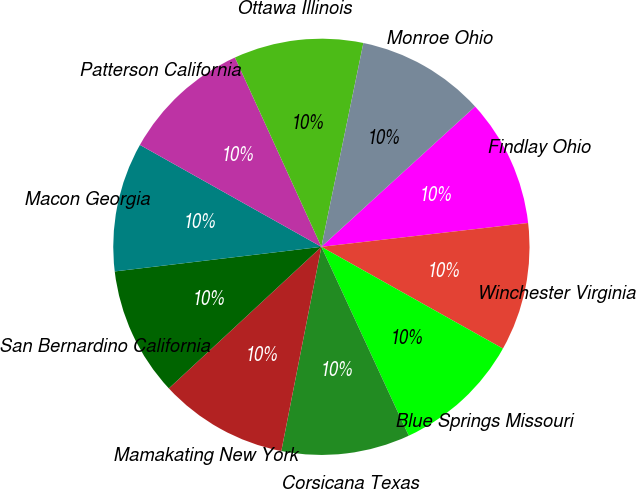Convert chart. <chart><loc_0><loc_0><loc_500><loc_500><pie_chart><fcel>Findlay Ohio<fcel>Winchester Virginia<fcel>Blue Springs Missouri<fcel>Corsicana Texas<fcel>Mamakating New York<fcel>San Bernardino California<fcel>Macon Georgia<fcel>Patterson California<fcel>Ottawa Illinois<fcel>Monroe Ohio<nl><fcel>9.95%<fcel>9.96%<fcel>9.97%<fcel>9.98%<fcel>10.01%<fcel>10.02%<fcel>10.03%<fcel>10.04%<fcel>10.05%<fcel>9.99%<nl></chart> 